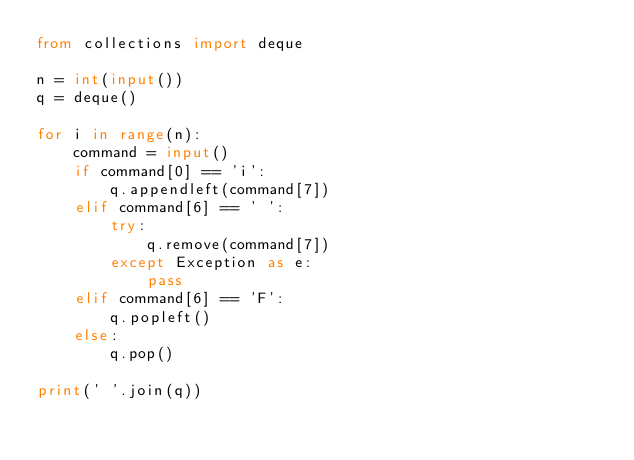<code> <loc_0><loc_0><loc_500><loc_500><_Python_>from collections import deque

n = int(input())
q = deque()

for i in range(n):
    command = input()
    if command[0] == 'i':
        q.appendleft(command[7])
    elif command[6] == ' ':
        try:
            q.remove(command[7])
        except Exception as e:
            pass
    elif command[6] == 'F':
        q.popleft()
    else:
        q.pop()

print(' '.join(q))</code> 